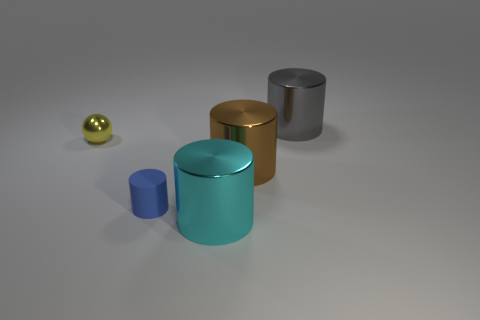Subtract 1 cylinders. How many cylinders are left? 3 Subtract all red cylinders. Subtract all blue cubes. How many cylinders are left? 4 Add 2 tiny green metallic balls. How many objects exist? 7 Subtract all cylinders. How many objects are left? 1 Subtract all cylinders. Subtract all tiny yellow shiny things. How many objects are left? 0 Add 1 yellow spheres. How many yellow spheres are left? 2 Add 3 gray shiny things. How many gray shiny things exist? 4 Subtract 1 gray cylinders. How many objects are left? 4 